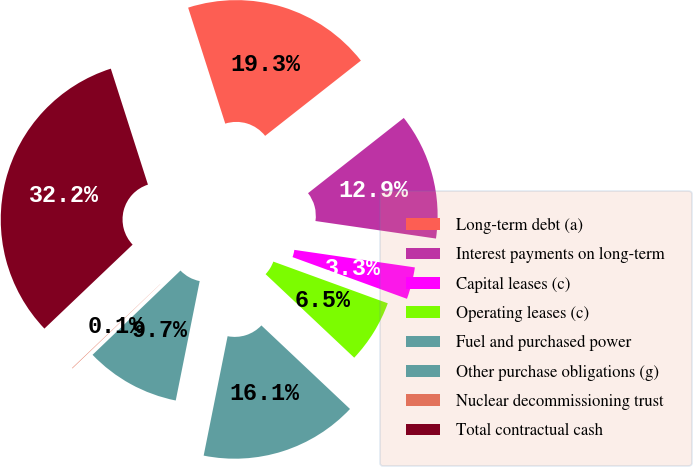Convert chart to OTSL. <chart><loc_0><loc_0><loc_500><loc_500><pie_chart><fcel>Long-term debt (a)<fcel>Interest payments on long-term<fcel>Capital leases (c)<fcel>Operating leases (c)<fcel>Fuel and purchased power<fcel>Other purchase obligations (g)<fcel>Nuclear decommissioning trust<fcel>Total contractual cash<nl><fcel>19.33%<fcel>12.9%<fcel>3.26%<fcel>6.47%<fcel>16.12%<fcel>9.69%<fcel>0.05%<fcel>32.18%<nl></chart> 